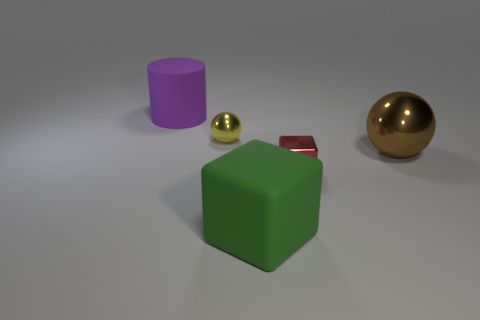Add 5 shiny spheres. How many objects exist? 10 Subtract all blocks. How many objects are left? 3 Subtract 0 blue blocks. How many objects are left? 5 Subtract all small red cubes. Subtract all yellow shiny things. How many objects are left? 3 Add 4 big green cubes. How many big green cubes are left? 5 Add 5 big blue matte cubes. How many big blue matte cubes exist? 5 